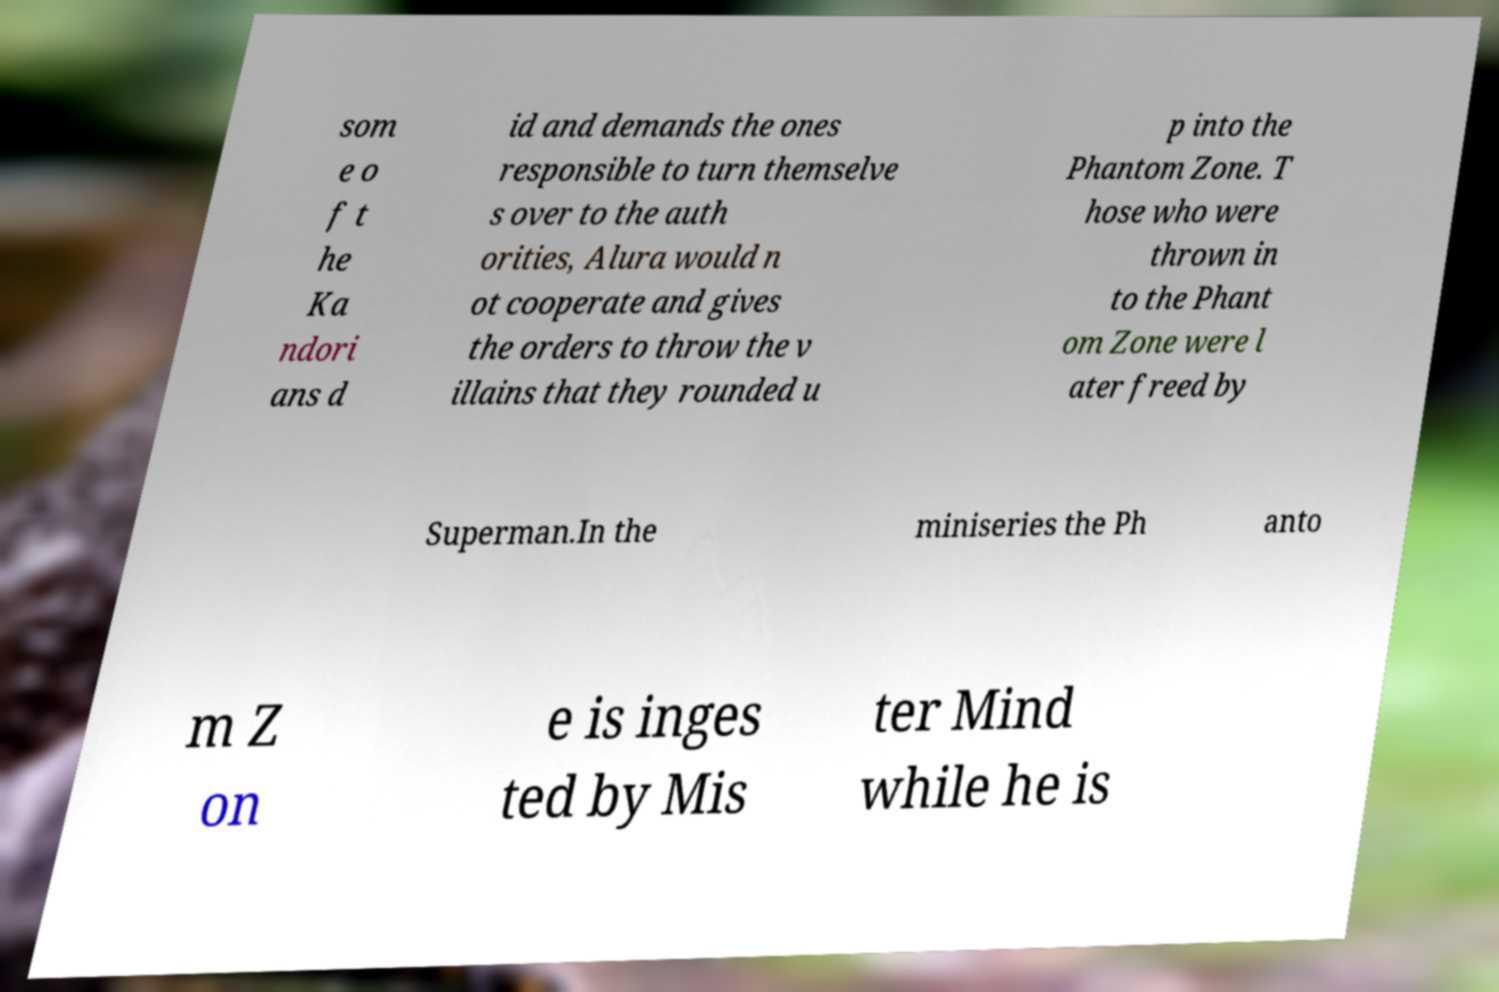I need the written content from this picture converted into text. Can you do that? som e o f t he Ka ndori ans d id and demands the ones responsible to turn themselve s over to the auth orities, Alura would n ot cooperate and gives the orders to throw the v illains that they rounded u p into the Phantom Zone. T hose who were thrown in to the Phant om Zone were l ater freed by Superman.In the miniseries the Ph anto m Z on e is inges ted by Mis ter Mind while he is 